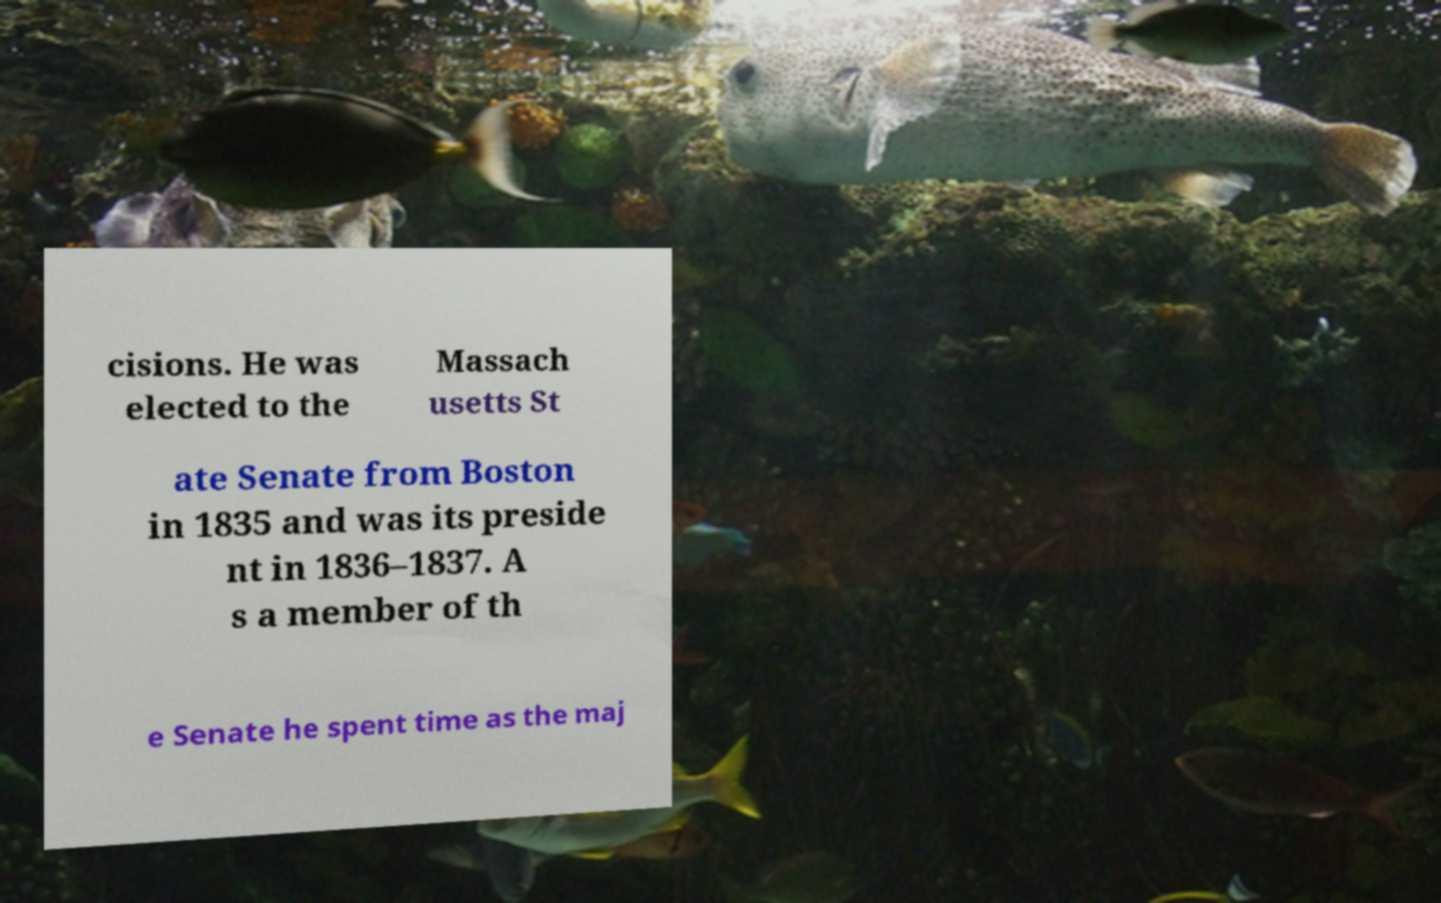Please read and relay the text visible in this image. What does it say? cisions. He was elected to the Massach usetts St ate Senate from Boston in 1835 and was its preside nt in 1836–1837. A s a member of th e Senate he spent time as the maj 